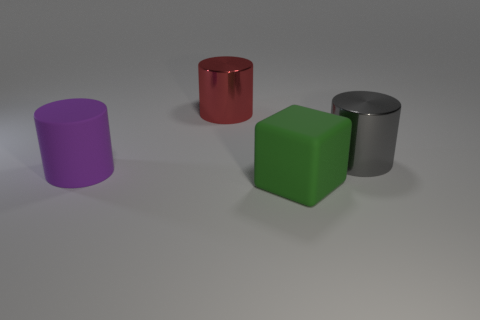Add 1 red metallic things. How many objects exist? 5 Subtract all cylinders. How many objects are left? 1 Add 1 green matte cubes. How many green matte cubes exist? 2 Subtract 0 yellow cylinders. How many objects are left? 4 Subtract all large matte things. Subtract all large cubes. How many objects are left? 1 Add 2 large cylinders. How many large cylinders are left? 5 